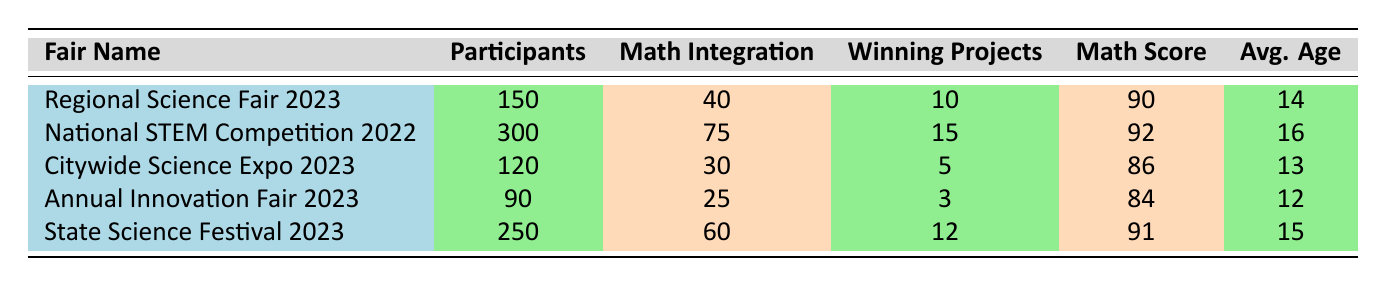How many participants were there in the National STEM Competition 2022? The table lists the number of participants for each fair. For the National STEM Competition 2022, the value is directly stated in the table as 300.
Answer: 300 What is the average score of the projects in the State Science Festival 2023? The average score for the State Science Festival 2023 is explicitly provided in the table, listed as 89.
Answer: 89 Which science fair had the highest math integration percentage? By comparing the "Math Integration" column, the National STEM Competition 2022 has the highest value at 75, indicating that it had the highest math integration.
Answer: National STEM Competition 2022 How many winning projects were there at the Citywide Science Expo 2023? The table states that the Citywide Science Expo 2023 had 5 winning projects listed in the appropriate column.
Answer: 5 What is the average participant age at the Annual Innovation Fair 2023? The average participant age is listed in the "Avg. Age" column for the Annual Innovation Fair 2023 as 12.
Answer: 12 What is the difference in the average scores between the National STEM Competition 2022 and the Annual Innovation Fair 2023? The average score for the National STEM Competition 2022 is 88 and for the Annual Innovation Fair 2023 it is 80. The difference is calculated as 88 - 80 = 8.
Answer: 8 Is the average score of the Regional Science Fair 2023 higher than that of the Citywide Science Expo 2023? The average score for the Regional Science Fair 2023 is 85, while for the Citywide Science Expo 2023 it is 82. Since 85 is greater than 82, the statement is true.
Answer: Yes What is the total number of participants across all science fairs listed? The total participants can be found by summing all individual participant numbers: 150 + 300 + 120 + 90 + 250 = 910.
Answer: 910 Which science fair had the lowest average participant age? By comparing the "Avg. Age" column, the Annual Innovation Fair 2023 has the lowest average participant age at 12.
Answer: Annual Innovation Fair 2023 If we consider only the fairs with more than 100 participants, what is the average math score of those fairs? The fairs with more than 100 participants are the National STEM Competition 2022, State Science Festival 2023, and Regional Science Fair 2023. Their math scores are 92, 91, and 90 respectively. The average is calculated as (92 + 91 + 90) / 3 = 91.
Answer: 91 What percentage of participants in the Citywide Science Expo 2023 integrated math components? To find the percentage, we take the number of math integration (30) and divide it by the total participants (120), then multiply by 100: (30 / 120) * 100 = 25%.
Answer: 25% 